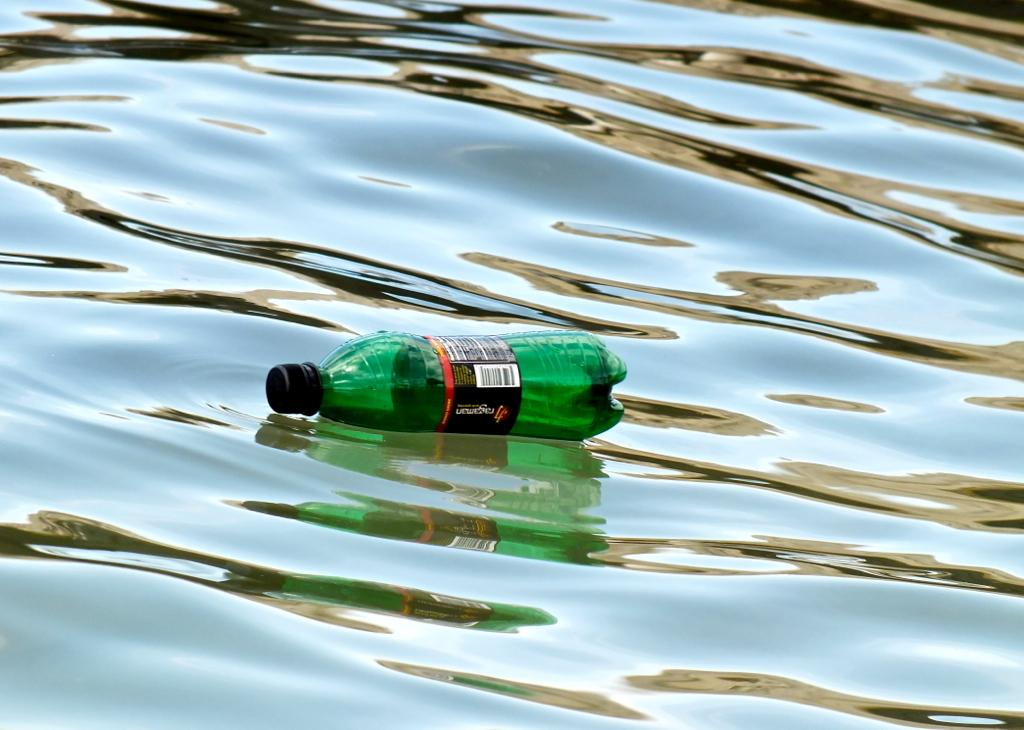What object is in the water in the image? There is a bottle in the water. Can you describe the position of the bottle in the water? The bottle is fully submerged in the water. What might be the purpose of the bottle being in the water? It is unclear from the image what the purpose of the bottle being in the water is. Is the bottle sinking in quicksand in the image? There is no quicksand present in the image, and the bottle is in the water, not quicksand. 